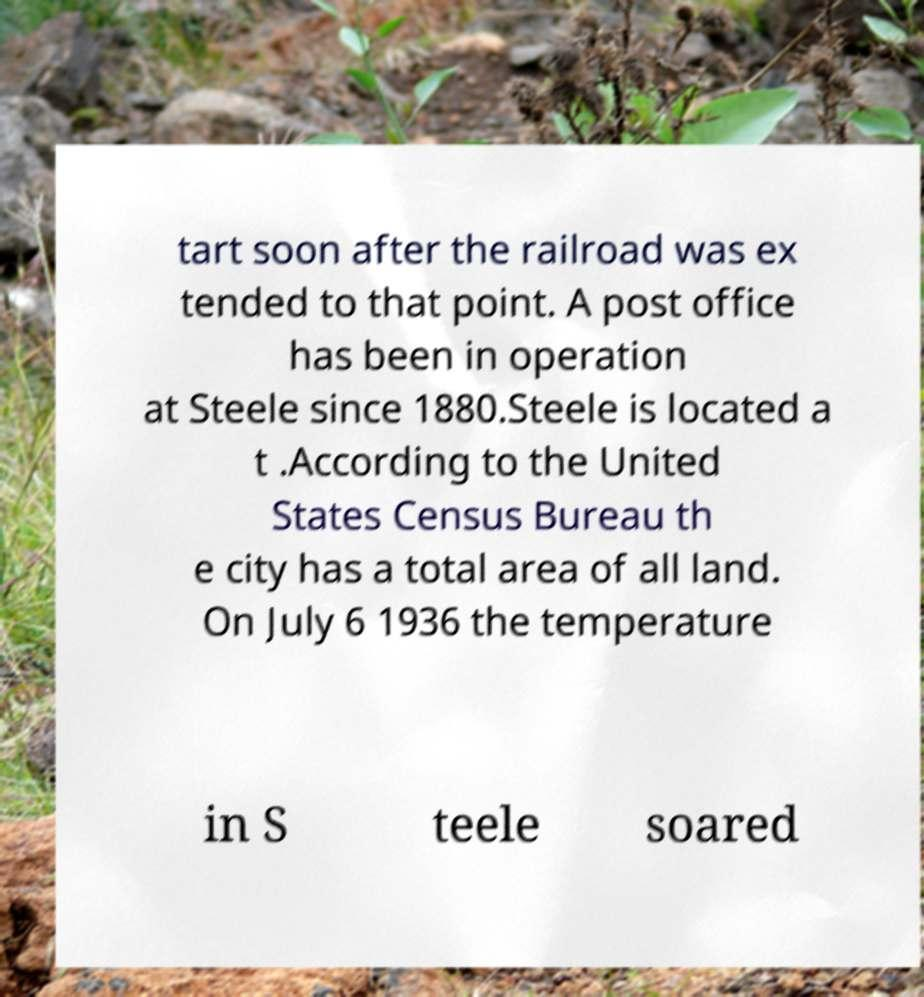Please read and relay the text visible in this image. What does it say? tart soon after the railroad was ex tended to that point. A post office has been in operation at Steele since 1880.Steele is located a t .According to the United States Census Bureau th e city has a total area of all land. On July 6 1936 the temperature in S teele soared 